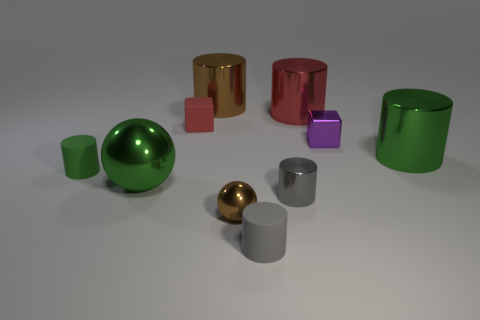Subtract all large brown cylinders. How many cylinders are left? 5 Subtract all cubes. How many objects are left? 8 Subtract all metal cylinders. Subtract all tiny purple shiny things. How many objects are left? 5 Add 2 small purple cubes. How many small purple cubes are left? 3 Add 5 large green matte cylinders. How many large green matte cylinders exist? 5 Subtract all red cylinders. How many cylinders are left? 5 Subtract 0 blue blocks. How many objects are left? 10 Subtract 2 balls. How many balls are left? 0 Subtract all brown cylinders. Subtract all yellow balls. How many cylinders are left? 5 Subtract all gray cylinders. How many red cubes are left? 1 